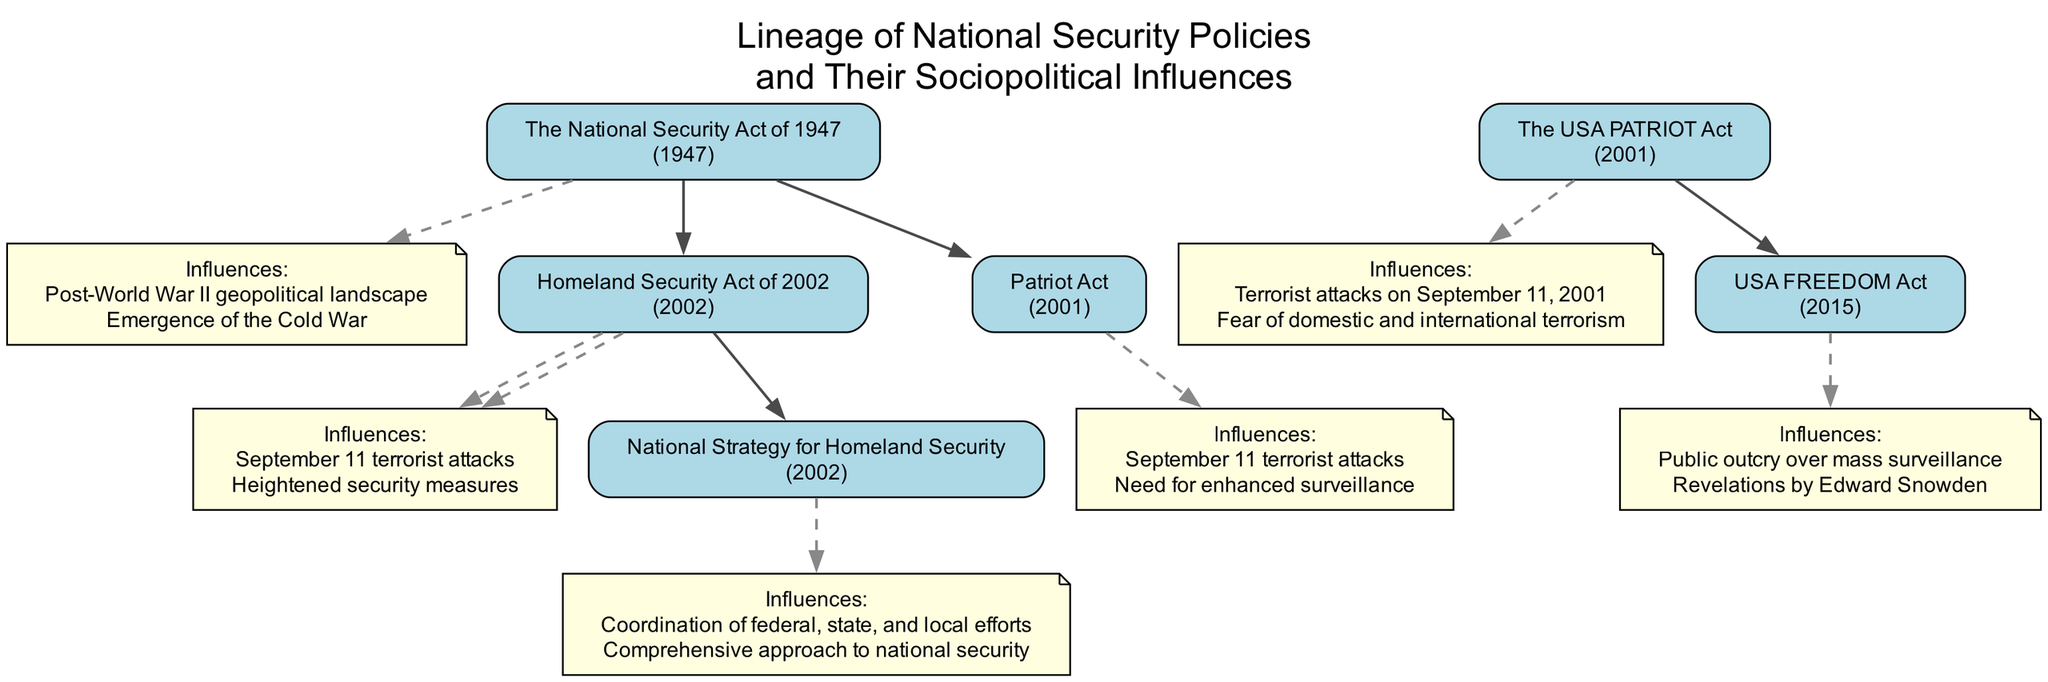What is the first national security policy listed in the diagram? The first national security policy mentioned is located at the top of the diagram. By reviewing the nodes in order, the first node is "The National Security Act of 1947".
Answer: The National Security Act of 1947 How many descendants does the USA PATRIOT Act have? The USA PATRIOT Act node has one descendant listed beneath it. By inspecting the layout, we see it leads to the USA FREEDOM Act node.
Answer: 1 What year was the Homeland Security Act enacted? By checking the label of the Homeland Security Act node in the diagram, we see the year indicated is 2002.
Answer: 2002 Which policy was influenced by the September 11 terrorist attacks? The diagram shows multiple policies influenced by the September 11 terrorist attacks; specifically, "Homeland Security Act of 2002" and "Patriot Act" both list this as an influence.
Answer: Homeland Security Act of 2002, Patriot Act What sociopolitical influence is shared by both the Patriot Act and the Homeland Security Act of 2002? By analyzing the influences listed for both acts, we identify "September 11 terrorist attacks" as a common influence.
Answer: September 11 terrorist attacks Which policy lineage includes an influence from Edward Snowden? The USA FREEDOM Act, which is a descendant of the USA PATRIOT Act, contains this influence as indicated in its note.
Answer: USA FREEDOM Act How many policies are listed as direct descendants of the National Security Act of 1947? Review the descendants of the National Security Act in the diagram. There are two policies: the Homeland Security Act of 2002 and the Patriot Act.
Answer: 2 Which national security policy was enacted first, the USA FREEDOM Act or the National Strategy for Homeland Security? The enactment years of the USA FREEDOM Act (2015) and the National Strategy for Homeland Security (2002) can be compared, showing the National Strategy for Homeland Security was enacted first.
Answer: National Strategy for Homeland Security What unique influence is attributed to the Homeland Security Act of 2002 that is not listed for the USA PATRIOT Act? The Homeland Security Act of 2002 specifically lists "Heightened security measures" as an influence, which is unique compared to the influences of the USA PATRIOT Act.
Answer: Heightened security measures 